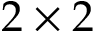Convert formula to latex. <formula><loc_0><loc_0><loc_500><loc_500>2 \times 2</formula> 